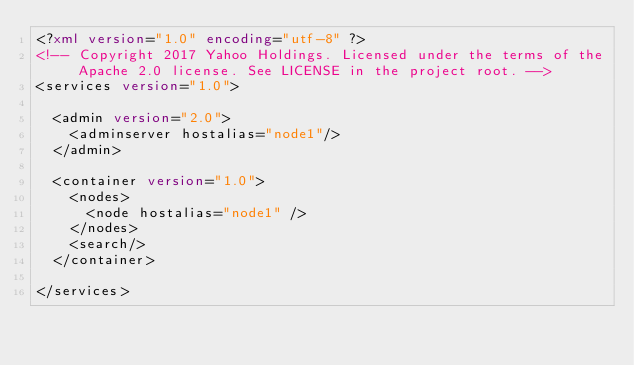<code> <loc_0><loc_0><loc_500><loc_500><_XML_><?xml version="1.0" encoding="utf-8" ?>
<!-- Copyright 2017 Yahoo Holdings. Licensed under the terms of the Apache 2.0 license. See LICENSE in the project root. -->
<services version="1.0">

  <admin version="2.0">
    <adminserver hostalias="node1"/>
  </admin>

  <container version="1.0">
    <nodes>
      <node hostalias="node1" />
    </nodes>
    <search/>
  </container>

</services>
</code> 